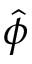<formula> <loc_0><loc_0><loc_500><loc_500>\hat { \phi }</formula> 